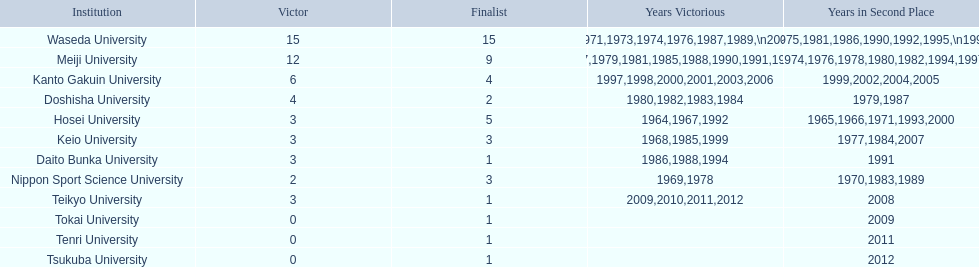Can you parse all the data within this table? {'header': ['Institution', 'Victor', 'Finalist', 'Years Victorious', 'Years in Second Place'], 'rows': [['Waseda University', '15', '15', '1965,1966,1968,1970,1971,1973,1974,1976,1987,1989,\\n2002,2004,2005,2007,2008', '1964,1967,1969,1972,1975,1981,1986,1990,1992,1995,\\n1996,2001,2003,2006,2010'], ['Meiji University', '12', '9', '1972,1975,1977,1979,1981,1985,1988,1990,1991,1993,\\n1995,1996', '1973,1974,1976,1978,1980,1982,1994,1997,1998'], ['Kanto Gakuin University', '6', '4', '1997,1998,2000,2001,2003,2006', '1999,2002,2004,2005'], ['Doshisha University', '4', '2', '1980,1982,1983,1984', '1979,1987'], ['Hosei University', '3', '5', '1964,1967,1992', '1965,1966,1971,1993,2000'], ['Keio University', '3', '3', '1968,1985,1999', '1977,1984,2007'], ['Daito Bunka University', '3', '1', '1986,1988,1994', '1991'], ['Nippon Sport Science University', '2', '3', '1969,1978', '1970,1983,1989'], ['Teikyo University', '3', '1', '2009,2010,2011,2012', '2008'], ['Tokai University', '0', '1', '', '2009'], ['Tenri University', '0', '1', '', '2011'], ['Tsukuba University', '0', '1', '', '2012']]} Who was the victor in 1965, following hosei's triumph in 1964? Waseda University. 